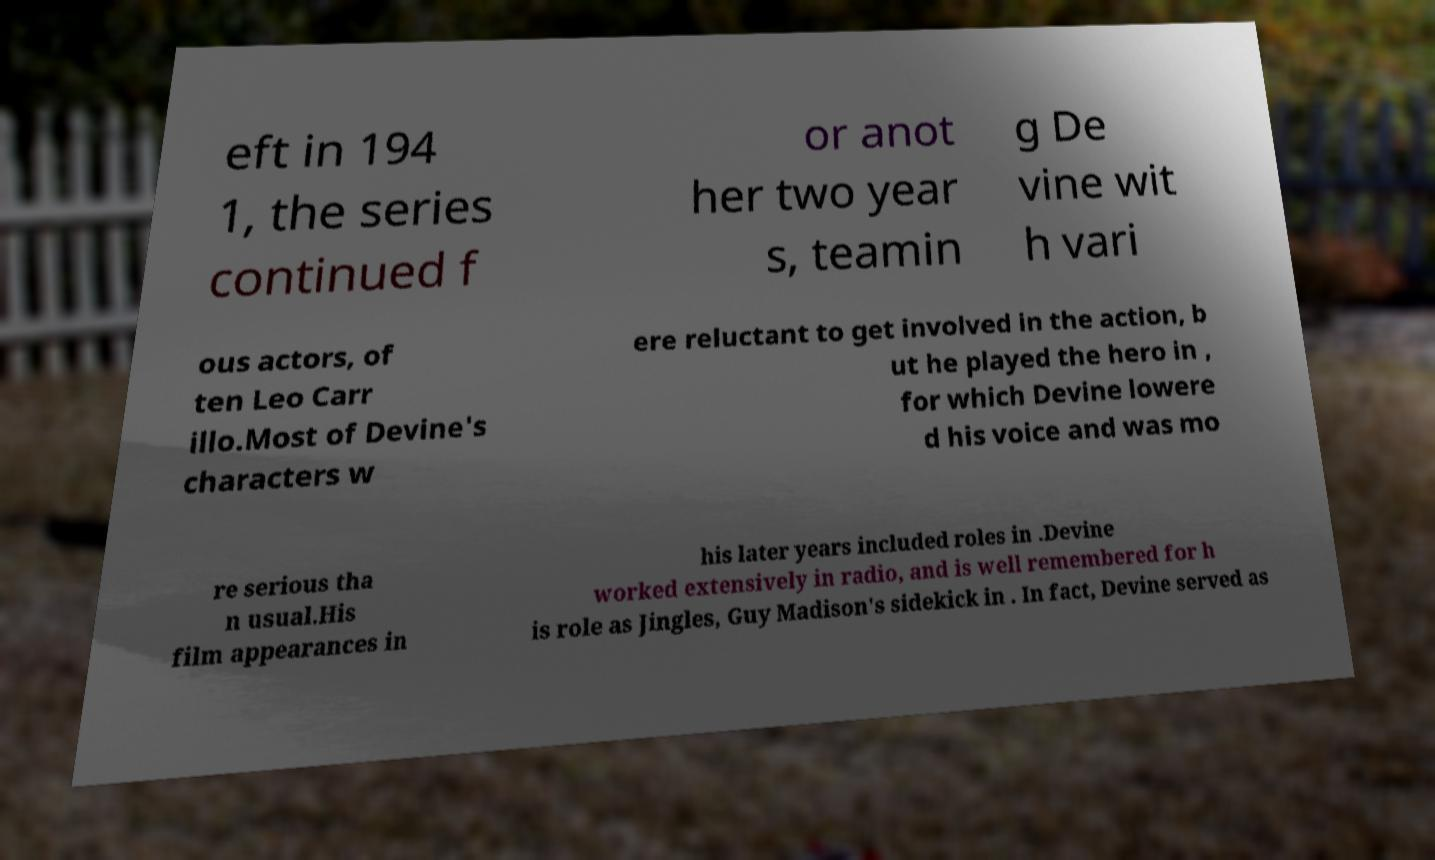I need the written content from this picture converted into text. Can you do that? eft in 194 1, the series continued f or anot her two year s, teamin g De vine wit h vari ous actors, of ten Leo Carr illo.Most of Devine's characters w ere reluctant to get involved in the action, b ut he played the hero in , for which Devine lowere d his voice and was mo re serious tha n usual.His film appearances in his later years included roles in .Devine worked extensively in radio, and is well remembered for h is role as Jingles, Guy Madison's sidekick in . In fact, Devine served as 